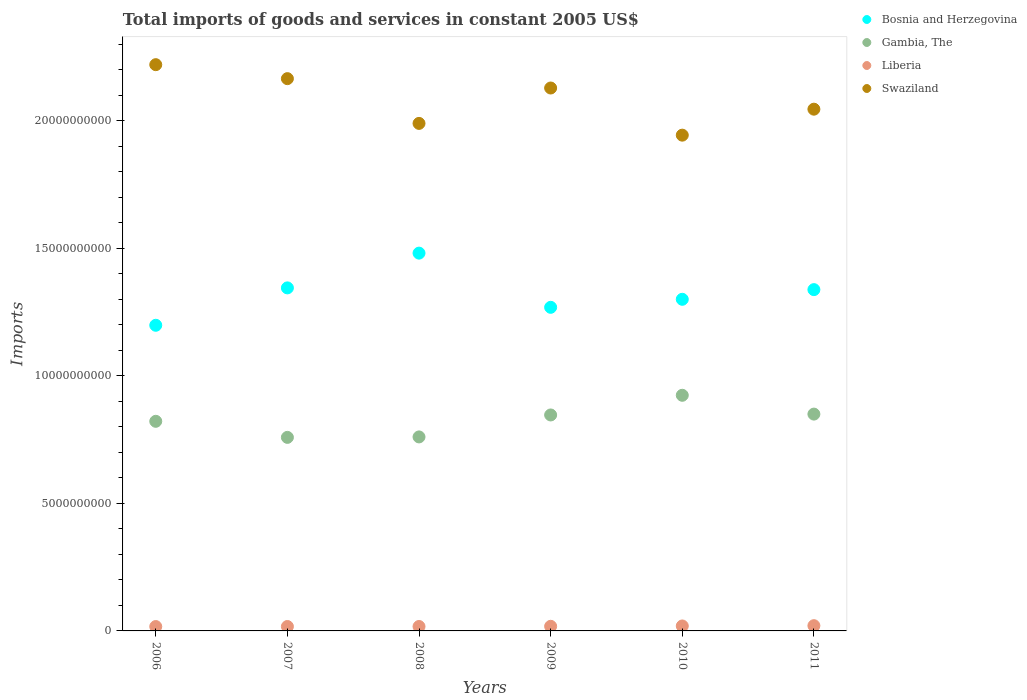How many different coloured dotlines are there?
Ensure brevity in your answer.  4. Is the number of dotlines equal to the number of legend labels?
Provide a short and direct response. Yes. What is the total imports of goods and services in Swaziland in 2010?
Your answer should be very brief. 1.94e+1. Across all years, what is the maximum total imports of goods and services in Liberia?
Provide a short and direct response. 2.06e+08. Across all years, what is the minimum total imports of goods and services in Gambia, The?
Keep it short and to the point. 7.59e+09. What is the total total imports of goods and services in Gambia, The in the graph?
Make the answer very short. 4.96e+1. What is the difference between the total imports of goods and services in Liberia in 2006 and that in 2010?
Your answer should be compact. -2.30e+07. What is the difference between the total imports of goods and services in Liberia in 2006 and the total imports of goods and services in Swaziland in 2007?
Your response must be concise. -2.15e+1. What is the average total imports of goods and services in Gambia, The per year?
Offer a terse response. 8.27e+09. In the year 2008, what is the difference between the total imports of goods and services in Gambia, The and total imports of goods and services in Swaziland?
Keep it short and to the point. -1.23e+1. What is the ratio of the total imports of goods and services in Gambia, The in 2007 to that in 2011?
Your answer should be very brief. 0.89. Is the total imports of goods and services in Bosnia and Herzegovina in 2008 less than that in 2010?
Keep it short and to the point. No. What is the difference between the highest and the second highest total imports of goods and services in Swaziland?
Give a very brief answer. 5.48e+08. What is the difference between the highest and the lowest total imports of goods and services in Gambia, The?
Offer a very short reply. 1.65e+09. In how many years, is the total imports of goods and services in Gambia, The greater than the average total imports of goods and services in Gambia, The taken over all years?
Your response must be concise. 3. Is the sum of the total imports of goods and services in Swaziland in 2008 and 2009 greater than the maximum total imports of goods and services in Gambia, The across all years?
Offer a very short reply. Yes. Does the total imports of goods and services in Bosnia and Herzegovina monotonically increase over the years?
Give a very brief answer. No. Is the total imports of goods and services in Swaziland strictly greater than the total imports of goods and services in Bosnia and Herzegovina over the years?
Provide a short and direct response. Yes. Is the total imports of goods and services in Swaziland strictly less than the total imports of goods and services in Gambia, The over the years?
Keep it short and to the point. No. How many years are there in the graph?
Your response must be concise. 6. What is the difference between two consecutive major ticks on the Y-axis?
Ensure brevity in your answer.  5.00e+09. Does the graph contain grids?
Your answer should be very brief. No. Where does the legend appear in the graph?
Ensure brevity in your answer.  Top right. How many legend labels are there?
Offer a very short reply. 4. How are the legend labels stacked?
Your response must be concise. Vertical. What is the title of the graph?
Offer a terse response. Total imports of goods and services in constant 2005 US$. Does "Kazakhstan" appear as one of the legend labels in the graph?
Provide a succinct answer. No. What is the label or title of the X-axis?
Ensure brevity in your answer.  Years. What is the label or title of the Y-axis?
Ensure brevity in your answer.  Imports. What is the Imports in Bosnia and Herzegovina in 2006?
Your response must be concise. 1.20e+1. What is the Imports of Gambia, The in 2006?
Your answer should be compact. 8.22e+09. What is the Imports of Liberia in 2006?
Your answer should be compact. 1.71e+08. What is the Imports in Swaziland in 2006?
Your answer should be very brief. 2.22e+1. What is the Imports of Bosnia and Herzegovina in 2007?
Provide a succinct answer. 1.35e+1. What is the Imports of Gambia, The in 2007?
Your response must be concise. 7.59e+09. What is the Imports of Liberia in 2007?
Your answer should be very brief. 1.73e+08. What is the Imports in Swaziland in 2007?
Your response must be concise. 2.17e+1. What is the Imports in Bosnia and Herzegovina in 2008?
Offer a terse response. 1.48e+1. What is the Imports in Gambia, The in 2008?
Offer a terse response. 7.61e+09. What is the Imports in Liberia in 2008?
Your answer should be very brief. 1.74e+08. What is the Imports in Swaziland in 2008?
Make the answer very short. 1.99e+1. What is the Imports in Bosnia and Herzegovina in 2009?
Offer a very short reply. 1.27e+1. What is the Imports in Gambia, The in 2009?
Provide a short and direct response. 8.47e+09. What is the Imports in Liberia in 2009?
Ensure brevity in your answer.  1.81e+08. What is the Imports in Swaziland in 2009?
Offer a very short reply. 2.13e+1. What is the Imports of Bosnia and Herzegovina in 2010?
Your answer should be very brief. 1.30e+1. What is the Imports of Gambia, The in 2010?
Provide a short and direct response. 9.24e+09. What is the Imports in Liberia in 2010?
Provide a short and direct response. 1.94e+08. What is the Imports of Swaziland in 2010?
Keep it short and to the point. 1.94e+1. What is the Imports in Bosnia and Herzegovina in 2011?
Your answer should be very brief. 1.34e+1. What is the Imports of Gambia, The in 2011?
Give a very brief answer. 8.50e+09. What is the Imports of Liberia in 2011?
Offer a very short reply. 2.06e+08. What is the Imports in Swaziland in 2011?
Your answer should be very brief. 2.05e+1. Across all years, what is the maximum Imports of Bosnia and Herzegovina?
Your answer should be very brief. 1.48e+1. Across all years, what is the maximum Imports in Gambia, The?
Your answer should be very brief. 9.24e+09. Across all years, what is the maximum Imports in Liberia?
Give a very brief answer. 2.06e+08. Across all years, what is the maximum Imports in Swaziland?
Your response must be concise. 2.22e+1. Across all years, what is the minimum Imports of Bosnia and Herzegovina?
Keep it short and to the point. 1.20e+1. Across all years, what is the minimum Imports in Gambia, The?
Provide a short and direct response. 7.59e+09. Across all years, what is the minimum Imports of Liberia?
Your answer should be very brief. 1.71e+08. Across all years, what is the minimum Imports in Swaziland?
Keep it short and to the point. 1.94e+1. What is the total Imports of Bosnia and Herzegovina in the graph?
Your response must be concise. 7.93e+1. What is the total Imports in Gambia, The in the graph?
Keep it short and to the point. 4.96e+1. What is the total Imports in Liberia in the graph?
Ensure brevity in your answer.  1.10e+09. What is the total Imports of Swaziland in the graph?
Give a very brief answer. 1.25e+11. What is the difference between the Imports of Bosnia and Herzegovina in 2006 and that in 2007?
Ensure brevity in your answer.  -1.47e+09. What is the difference between the Imports in Gambia, The in 2006 and that in 2007?
Offer a terse response. 6.30e+08. What is the difference between the Imports in Liberia in 2006 and that in 2007?
Make the answer very short. -1.79e+06. What is the difference between the Imports in Swaziland in 2006 and that in 2007?
Your answer should be compact. 5.48e+08. What is the difference between the Imports in Bosnia and Herzegovina in 2006 and that in 2008?
Your answer should be very brief. -2.83e+09. What is the difference between the Imports in Gambia, The in 2006 and that in 2008?
Make the answer very short. 6.12e+08. What is the difference between the Imports in Liberia in 2006 and that in 2008?
Provide a short and direct response. -2.40e+06. What is the difference between the Imports in Swaziland in 2006 and that in 2008?
Make the answer very short. 2.30e+09. What is the difference between the Imports in Bosnia and Herzegovina in 2006 and that in 2009?
Your answer should be compact. -7.04e+08. What is the difference between the Imports in Gambia, The in 2006 and that in 2009?
Your response must be concise. -2.49e+08. What is the difference between the Imports in Liberia in 2006 and that in 2009?
Your response must be concise. -9.72e+06. What is the difference between the Imports of Swaziland in 2006 and that in 2009?
Your response must be concise. 9.15e+08. What is the difference between the Imports of Bosnia and Herzegovina in 2006 and that in 2010?
Offer a terse response. -1.02e+09. What is the difference between the Imports in Gambia, The in 2006 and that in 2010?
Offer a very short reply. -1.02e+09. What is the difference between the Imports in Liberia in 2006 and that in 2010?
Your answer should be very brief. -2.30e+07. What is the difference between the Imports of Swaziland in 2006 and that in 2010?
Provide a short and direct response. 2.76e+09. What is the difference between the Imports of Bosnia and Herzegovina in 2006 and that in 2011?
Ensure brevity in your answer.  -1.40e+09. What is the difference between the Imports in Gambia, The in 2006 and that in 2011?
Your answer should be compact. -2.83e+08. What is the difference between the Imports in Liberia in 2006 and that in 2011?
Your answer should be compact. -3.45e+07. What is the difference between the Imports in Swaziland in 2006 and that in 2011?
Offer a terse response. 1.75e+09. What is the difference between the Imports in Bosnia and Herzegovina in 2007 and that in 2008?
Make the answer very short. -1.36e+09. What is the difference between the Imports in Gambia, The in 2007 and that in 2008?
Offer a terse response. -1.79e+07. What is the difference between the Imports in Liberia in 2007 and that in 2008?
Keep it short and to the point. -6.03e+05. What is the difference between the Imports of Swaziland in 2007 and that in 2008?
Provide a succinct answer. 1.76e+09. What is the difference between the Imports in Bosnia and Herzegovina in 2007 and that in 2009?
Keep it short and to the point. 7.62e+08. What is the difference between the Imports in Gambia, The in 2007 and that in 2009?
Keep it short and to the point. -8.79e+08. What is the difference between the Imports of Liberia in 2007 and that in 2009?
Make the answer very short. -7.93e+06. What is the difference between the Imports in Swaziland in 2007 and that in 2009?
Your answer should be very brief. 3.67e+08. What is the difference between the Imports in Bosnia and Herzegovina in 2007 and that in 2010?
Your response must be concise. 4.48e+08. What is the difference between the Imports in Gambia, The in 2007 and that in 2010?
Offer a terse response. -1.65e+09. What is the difference between the Imports in Liberia in 2007 and that in 2010?
Your answer should be compact. -2.12e+07. What is the difference between the Imports of Swaziland in 2007 and that in 2010?
Provide a short and direct response. 2.22e+09. What is the difference between the Imports in Bosnia and Herzegovina in 2007 and that in 2011?
Give a very brief answer. 6.82e+07. What is the difference between the Imports of Gambia, The in 2007 and that in 2011?
Ensure brevity in your answer.  -9.13e+08. What is the difference between the Imports in Liberia in 2007 and that in 2011?
Give a very brief answer. -3.27e+07. What is the difference between the Imports in Swaziland in 2007 and that in 2011?
Give a very brief answer. 1.20e+09. What is the difference between the Imports in Bosnia and Herzegovina in 2008 and that in 2009?
Offer a terse response. 2.13e+09. What is the difference between the Imports in Gambia, The in 2008 and that in 2009?
Give a very brief answer. -8.61e+08. What is the difference between the Imports of Liberia in 2008 and that in 2009?
Keep it short and to the point. -7.32e+06. What is the difference between the Imports of Swaziland in 2008 and that in 2009?
Offer a very short reply. -1.39e+09. What is the difference between the Imports in Bosnia and Herzegovina in 2008 and that in 2010?
Offer a very short reply. 1.81e+09. What is the difference between the Imports in Gambia, The in 2008 and that in 2010?
Make the answer very short. -1.63e+09. What is the difference between the Imports of Liberia in 2008 and that in 2010?
Offer a very short reply. -2.06e+07. What is the difference between the Imports of Swaziland in 2008 and that in 2010?
Provide a succinct answer. 4.61e+08. What is the difference between the Imports of Bosnia and Herzegovina in 2008 and that in 2011?
Provide a succinct answer. 1.43e+09. What is the difference between the Imports of Gambia, The in 2008 and that in 2011?
Provide a short and direct response. -8.95e+08. What is the difference between the Imports of Liberia in 2008 and that in 2011?
Your answer should be compact. -3.21e+07. What is the difference between the Imports in Swaziland in 2008 and that in 2011?
Offer a very short reply. -5.58e+08. What is the difference between the Imports of Bosnia and Herzegovina in 2009 and that in 2010?
Keep it short and to the point. -3.15e+08. What is the difference between the Imports in Gambia, The in 2009 and that in 2010?
Provide a succinct answer. -7.72e+08. What is the difference between the Imports in Liberia in 2009 and that in 2010?
Give a very brief answer. -1.32e+07. What is the difference between the Imports of Swaziland in 2009 and that in 2010?
Your answer should be very brief. 1.85e+09. What is the difference between the Imports of Bosnia and Herzegovina in 2009 and that in 2011?
Your answer should be compact. -6.94e+08. What is the difference between the Imports in Gambia, The in 2009 and that in 2011?
Offer a terse response. -3.38e+07. What is the difference between the Imports of Liberia in 2009 and that in 2011?
Your response must be concise. -2.48e+07. What is the difference between the Imports of Swaziland in 2009 and that in 2011?
Provide a succinct answer. 8.30e+08. What is the difference between the Imports of Bosnia and Herzegovina in 2010 and that in 2011?
Keep it short and to the point. -3.79e+08. What is the difference between the Imports in Gambia, The in 2010 and that in 2011?
Provide a succinct answer. 7.38e+08. What is the difference between the Imports of Liberia in 2010 and that in 2011?
Provide a succinct answer. -1.15e+07. What is the difference between the Imports of Swaziland in 2010 and that in 2011?
Your response must be concise. -1.02e+09. What is the difference between the Imports in Bosnia and Herzegovina in 2006 and the Imports in Gambia, The in 2007?
Offer a terse response. 4.40e+09. What is the difference between the Imports of Bosnia and Herzegovina in 2006 and the Imports of Liberia in 2007?
Offer a very short reply. 1.18e+1. What is the difference between the Imports in Bosnia and Herzegovina in 2006 and the Imports in Swaziland in 2007?
Offer a terse response. -9.67e+09. What is the difference between the Imports of Gambia, The in 2006 and the Imports of Liberia in 2007?
Your response must be concise. 8.05e+09. What is the difference between the Imports in Gambia, The in 2006 and the Imports in Swaziland in 2007?
Offer a terse response. -1.34e+1. What is the difference between the Imports in Liberia in 2006 and the Imports in Swaziland in 2007?
Provide a succinct answer. -2.15e+1. What is the difference between the Imports of Bosnia and Herzegovina in 2006 and the Imports of Gambia, The in 2008?
Offer a very short reply. 4.38e+09. What is the difference between the Imports in Bosnia and Herzegovina in 2006 and the Imports in Liberia in 2008?
Your answer should be very brief. 1.18e+1. What is the difference between the Imports of Bosnia and Herzegovina in 2006 and the Imports of Swaziland in 2008?
Make the answer very short. -7.92e+09. What is the difference between the Imports in Gambia, The in 2006 and the Imports in Liberia in 2008?
Your answer should be compact. 8.05e+09. What is the difference between the Imports in Gambia, The in 2006 and the Imports in Swaziland in 2008?
Offer a very short reply. -1.17e+1. What is the difference between the Imports in Liberia in 2006 and the Imports in Swaziland in 2008?
Your answer should be compact. -1.97e+1. What is the difference between the Imports in Bosnia and Herzegovina in 2006 and the Imports in Gambia, The in 2009?
Your answer should be very brief. 3.52e+09. What is the difference between the Imports in Bosnia and Herzegovina in 2006 and the Imports in Liberia in 2009?
Your answer should be very brief. 1.18e+1. What is the difference between the Imports of Bosnia and Herzegovina in 2006 and the Imports of Swaziland in 2009?
Offer a terse response. -9.31e+09. What is the difference between the Imports of Gambia, The in 2006 and the Imports of Liberia in 2009?
Give a very brief answer. 8.04e+09. What is the difference between the Imports in Gambia, The in 2006 and the Imports in Swaziland in 2009?
Your answer should be very brief. -1.31e+1. What is the difference between the Imports of Liberia in 2006 and the Imports of Swaziland in 2009?
Provide a succinct answer. -2.11e+1. What is the difference between the Imports in Bosnia and Herzegovina in 2006 and the Imports in Gambia, The in 2010?
Make the answer very short. 2.75e+09. What is the difference between the Imports of Bosnia and Herzegovina in 2006 and the Imports of Liberia in 2010?
Offer a terse response. 1.18e+1. What is the difference between the Imports in Bosnia and Herzegovina in 2006 and the Imports in Swaziland in 2010?
Provide a succinct answer. -7.46e+09. What is the difference between the Imports in Gambia, The in 2006 and the Imports in Liberia in 2010?
Offer a very short reply. 8.03e+09. What is the difference between the Imports in Gambia, The in 2006 and the Imports in Swaziland in 2010?
Offer a very short reply. -1.12e+1. What is the difference between the Imports in Liberia in 2006 and the Imports in Swaziland in 2010?
Offer a very short reply. -1.93e+1. What is the difference between the Imports of Bosnia and Herzegovina in 2006 and the Imports of Gambia, The in 2011?
Keep it short and to the point. 3.48e+09. What is the difference between the Imports of Bosnia and Herzegovina in 2006 and the Imports of Liberia in 2011?
Your response must be concise. 1.18e+1. What is the difference between the Imports in Bosnia and Herzegovina in 2006 and the Imports in Swaziland in 2011?
Provide a short and direct response. -8.47e+09. What is the difference between the Imports in Gambia, The in 2006 and the Imports in Liberia in 2011?
Offer a terse response. 8.01e+09. What is the difference between the Imports of Gambia, The in 2006 and the Imports of Swaziland in 2011?
Your response must be concise. -1.22e+1. What is the difference between the Imports of Liberia in 2006 and the Imports of Swaziland in 2011?
Give a very brief answer. -2.03e+1. What is the difference between the Imports in Bosnia and Herzegovina in 2007 and the Imports in Gambia, The in 2008?
Your response must be concise. 5.84e+09. What is the difference between the Imports of Bosnia and Herzegovina in 2007 and the Imports of Liberia in 2008?
Provide a short and direct response. 1.33e+1. What is the difference between the Imports of Bosnia and Herzegovina in 2007 and the Imports of Swaziland in 2008?
Give a very brief answer. -6.45e+09. What is the difference between the Imports in Gambia, The in 2007 and the Imports in Liberia in 2008?
Ensure brevity in your answer.  7.42e+09. What is the difference between the Imports of Gambia, The in 2007 and the Imports of Swaziland in 2008?
Keep it short and to the point. -1.23e+1. What is the difference between the Imports in Liberia in 2007 and the Imports in Swaziland in 2008?
Ensure brevity in your answer.  -1.97e+1. What is the difference between the Imports in Bosnia and Herzegovina in 2007 and the Imports in Gambia, The in 2009?
Provide a short and direct response. 4.98e+09. What is the difference between the Imports in Bosnia and Herzegovina in 2007 and the Imports in Liberia in 2009?
Your answer should be compact. 1.33e+1. What is the difference between the Imports of Bosnia and Herzegovina in 2007 and the Imports of Swaziland in 2009?
Ensure brevity in your answer.  -7.84e+09. What is the difference between the Imports of Gambia, The in 2007 and the Imports of Liberia in 2009?
Provide a short and direct response. 7.41e+09. What is the difference between the Imports in Gambia, The in 2007 and the Imports in Swaziland in 2009?
Your answer should be very brief. -1.37e+1. What is the difference between the Imports in Liberia in 2007 and the Imports in Swaziland in 2009?
Make the answer very short. -2.11e+1. What is the difference between the Imports of Bosnia and Herzegovina in 2007 and the Imports of Gambia, The in 2010?
Your answer should be very brief. 4.21e+09. What is the difference between the Imports in Bosnia and Herzegovina in 2007 and the Imports in Liberia in 2010?
Give a very brief answer. 1.33e+1. What is the difference between the Imports in Bosnia and Herzegovina in 2007 and the Imports in Swaziland in 2010?
Offer a terse response. -5.99e+09. What is the difference between the Imports in Gambia, The in 2007 and the Imports in Liberia in 2010?
Ensure brevity in your answer.  7.40e+09. What is the difference between the Imports in Gambia, The in 2007 and the Imports in Swaziland in 2010?
Keep it short and to the point. -1.19e+1. What is the difference between the Imports of Liberia in 2007 and the Imports of Swaziland in 2010?
Your response must be concise. -1.93e+1. What is the difference between the Imports in Bosnia and Herzegovina in 2007 and the Imports in Gambia, The in 2011?
Ensure brevity in your answer.  4.95e+09. What is the difference between the Imports in Bosnia and Herzegovina in 2007 and the Imports in Liberia in 2011?
Offer a terse response. 1.32e+1. What is the difference between the Imports of Bosnia and Herzegovina in 2007 and the Imports of Swaziland in 2011?
Your answer should be very brief. -7.01e+09. What is the difference between the Imports in Gambia, The in 2007 and the Imports in Liberia in 2011?
Make the answer very short. 7.38e+09. What is the difference between the Imports of Gambia, The in 2007 and the Imports of Swaziland in 2011?
Ensure brevity in your answer.  -1.29e+1. What is the difference between the Imports of Liberia in 2007 and the Imports of Swaziland in 2011?
Give a very brief answer. -2.03e+1. What is the difference between the Imports in Bosnia and Herzegovina in 2008 and the Imports in Gambia, The in 2009?
Give a very brief answer. 6.35e+09. What is the difference between the Imports of Bosnia and Herzegovina in 2008 and the Imports of Liberia in 2009?
Offer a terse response. 1.46e+1. What is the difference between the Imports of Bosnia and Herzegovina in 2008 and the Imports of Swaziland in 2009?
Provide a succinct answer. -6.48e+09. What is the difference between the Imports of Gambia, The in 2008 and the Imports of Liberia in 2009?
Provide a short and direct response. 7.43e+09. What is the difference between the Imports in Gambia, The in 2008 and the Imports in Swaziland in 2009?
Your response must be concise. -1.37e+1. What is the difference between the Imports in Liberia in 2008 and the Imports in Swaziland in 2009?
Your answer should be very brief. -2.11e+1. What is the difference between the Imports of Bosnia and Herzegovina in 2008 and the Imports of Gambia, The in 2010?
Give a very brief answer. 5.57e+09. What is the difference between the Imports in Bosnia and Herzegovina in 2008 and the Imports in Liberia in 2010?
Provide a short and direct response. 1.46e+1. What is the difference between the Imports of Bosnia and Herzegovina in 2008 and the Imports of Swaziland in 2010?
Provide a short and direct response. -4.63e+09. What is the difference between the Imports in Gambia, The in 2008 and the Imports in Liberia in 2010?
Offer a terse response. 7.41e+09. What is the difference between the Imports in Gambia, The in 2008 and the Imports in Swaziland in 2010?
Offer a very short reply. -1.18e+1. What is the difference between the Imports of Liberia in 2008 and the Imports of Swaziland in 2010?
Offer a very short reply. -1.93e+1. What is the difference between the Imports of Bosnia and Herzegovina in 2008 and the Imports of Gambia, The in 2011?
Keep it short and to the point. 6.31e+09. What is the difference between the Imports in Bosnia and Herzegovina in 2008 and the Imports in Liberia in 2011?
Give a very brief answer. 1.46e+1. What is the difference between the Imports in Bosnia and Herzegovina in 2008 and the Imports in Swaziland in 2011?
Offer a terse response. -5.65e+09. What is the difference between the Imports in Gambia, The in 2008 and the Imports in Liberia in 2011?
Give a very brief answer. 7.40e+09. What is the difference between the Imports of Gambia, The in 2008 and the Imports of Swaziland in 2011?
Offer a very short reply. -1.29e+1. What is the difference between the Imports in Liberia in 2008 and the Imports in Swaziland in 2011?
Your response must be concise. -2.03e+1. What is the difference between the Imports in Bosnia and Herzegovina in 2009 and the Imports in Gambia, The in 2010?
Provide a short and direct response. 3.45e+09. What is the difference between the Imports of Bosnia and Herzegovina in 2009 and the Imports of Liberia in 2010?
Provide a succinct answer. 1.25e+1. What is the difference between the Imports of Bosnia and Herzegovina in 2009 and the Imports of Swaziland in 2010?
Your answer should be compact. -6.75e+09. What is the difference between the Imports of Gambia, The in 2009 and the Imports of Liberia in 2010?
Offer a very short reply. 8.28e+09. What is the difference between the Imports in Gambia, The in 2009 and the Imports in Swaziland in 2010?
Provide a succinct answer. -1.10e+1. What is the difference between the Imports in Liberia in 2009 and the Imports in Swaziland in 2010?
Offer a very short reply. -1.93e+1. What is the difference between the Imports of Bosnia and Herzegovina in 2009 and the Imports of Gambia, The in 2011?
Offer a terse response. 4.19e+09. What is the difference between the Imports in Bosnia and Herzegovina in 2009 and the Imports in Liberia in 2011?
Your answer should be very brief. 1.25e+1. What is the difference between the Imports of Bosnia and Herzegovina in 2009 and the Imports of Swaziland in 2011?
Your answer should be very brief. -7.77e+09. What is the difference between the Imports of Gambia, The in 2009 and the Imports of Liberia in 2011?
Make the answer very short. 8.26e+09. What is the difference between the Imports of Gambia, The in 2009 and the Imports of Swaziland in 2011?
Provide a succinct answer. -1.20e+1. What is the difference between the Imports of Liberia in 2009 and the Imports of Swaziland in 2011?
Your answer should be very brief. -2.03e+1. What is the difference between the Imports of Bosnia and Herzegovina in 2010 and the Imports of Gambia, The in 2011?
Offer a very short reply. 4.50e+09. What is the difference between the Imports of Bosnia and Herzegovina in 2010 and the Imports of Liberia in 2011?
Make the answer very short. 1.28e+1. What is the difference between the Imports in Bosnia and Herzegovina in 2010 and the Imports in Swaziland in 2011?
Provide a succinct answer. -7.46e+09. What is the difference between the Imports in Gambia, The in 2010 and the Imports in Liberia in 2011?
Your answer should be very brief. 9.04e+09. What is the difference between the Imports of Gambia, The in 2010 and the Imports of Swaziland in 2011?
Your response must be concise. -1.12e+1. What is the difference between the Imports in Liberia in 2010 and the Imports in Swaziland in 2011?
Offer a terse response. -2.03e+1. What is the average Imports of Bosnia and Herzegovina per year?
Provide a succinct answer. 1.32e+1. What is the average Imports of Gambia, The per year?
Your response must be concise. 8.27e+09. What is the average Imports in Liberia per year?
Make the answer very short. 1.83e+08. What is the average Imports of Swaziland per year?
Make the answer very short. 2.08e+1. In the year 2006, what is the difference between the Imports in Bosnia and Herzegovina and Imports in Gambia, The?
Make the answer very short. 3.77e+09. In the year 2006, what is the difference between the Imports in Bosnia and Herzegovina and Imports in Liberia?
Give a very brief answer. 1.18e+1. In the year 2006, what is the difference between the Imports of Bosnia and Herzegovina and Imports of Swaziland?
Provide a succinct answer. -1.02e+1. In the year 2006, what is the difference between the Imports of Gambia, The and Imports of Liberia?
Your answer should be very brief. 8.05e+09. In the year 2006, what is the difference between the Imports in Gambia, The and Imports in Swaziland?
Provide a short and direct response. -1.40e+1. In the year 2006, what is the difference between the Imports in Liberia and Imports in Swaziland?
Your response must be concise. -2.20e+1. In the year 2007, what is the difference between the Imports in Bosnia and Herzegovina and Imports in Gambia, The?
Keep it short and to the point. 5.86e+09. In the year 2007, what is the difference between the Imports of Bosnia and Herzegovina and Imports of Liberia?
Provide a short and direct response. 1.33e+1. In the year 2007, what is the difference between the Imports in Bosnia and Herzegovina and Imports in Swaziland?
Provide a short and direct response. -8.21e+09. In the year 2007, what is the difference between the Imports in Gambia, The and Imports in Liberia?
Your answer should be very brief. 7.42e+09. In the year 2007, what is the difference between the Imports of Gambia, The and Imports of Swaziland?
Provide a short and direct response. -1.41e+1. In the year 2007, what is the difference between the Imports of Liberia and Imports of Swaziland?
Offer a terse response. -2.15e+1. In the year 2008, what is the difference between the Imports of Bosnia and Herzegovina and Imports of Gambia, The?
Your answer should be very brief. 7.21e+09. In the year 2008, what is the difference between the Imports in Bosnia and Herzegovina and Imports in Liberia?
Offer a terse response. 1.46e+1. In the year 2008, what is the difference between the Imports of Bosnia and Herzegovina and Imports of Swaziland?
Offer a very short reply. -5.09e+09. In the year 2008, what is the difference between the Imports of Gambia, The and Imports of Liberia?
Your answer should be compact. 7.43e+09. In the year 2008, what is the difference between the Imports in Gambia, The and Imports in Swaziland?
Your response must be concise. -1.23e+1. In the year 2008, what is the difference between the Imports in Liberia and Imports in Swaziland?
Make the answer very short. -1.97e+1. In the year 2009, what is the difference between the Imports of Bosnia and Herzegovina and Imports of Gambia, The?
Provide a short and direct response. 4.22e+09. In the year 2009, what is the difference between the Imports of Bosnia and Herzegovina and Imports of Liberia?
Make the answer very short. 1.25e+1. In the year 2009, what is the difference between the Imports in Bosnia and Herzegovina and Imports in Swaziland?
Your response must be concise. -8.60e+09. In the year 2009, what is the difference between the Imports of Gambia, The and Imports of Liberia?
Ensure brevity in your answer.  8.29e+09. In the year 2009, what is the difference between the Imports of Gambia, The and Imports of Swaziland?
Keep it short and to the point. -1.28e+1. In the year 2009, what is the difference between the Imports of Liberia and Imports of Swaziland?
Your answer should be compact. -2.11e+1. In the year 2010, what is the difference between the Imports of Bosnia and Herzegovina and Imports of Gambia, The?
Your answer should be compact. 3.76e+09. In the year 2010, what is the difference between the Imports of Bosnia and Herzegovina and Imports of Liberia?
Provide a short and direct response. 1.28e+1. In the year 2010, what is the difference between the Imports of Bosnia and Herzegovina and Imports of Swaziland?
Offer a very short reply. -6.44e+09. In the year 2010, what is the difference between the Imports in Gambia, The and Imports in Liberia?
Ensure brevity in your answer.  9.05e+09. In the year 2010, what is the difference between the Imports of Gambia, The and Imports of Swaziland?
Make the answer very short. -1.02e+1. In the year 2010, what is the difference between the Imports of Liberia and Imports of Swaziland?
Offer a very short reply. -1.92e+1. In the year 2011, what is the difference between the Imports in Bosnia and Herzegovina and Imports in Gambia, The?
Your response must be concise. 4.88e+09. In the year 2011, what is the difference between the Imports in Bosnia and Herzegovina and Imports in Liberia?
Your answer should be very brief. 1.32e+1. In the year 2011, what is the difference between the Imports of Bosnia and Herzegovina and Imports of Swaziland?
Make the answer very short. -7.08e+09. In the year 2011, what is the difference between the Imports of Gambia, The and Imports of Liberia?
Your answer should be compact. 8.30e+09. In the year 2011, what is the difference between the Imports in Gambia, The and Imports in Swaziland?
Your answer should be compact. -1.20e+1. In the year 2011, what is the difference between the Imports in Liberia and Imports in Swaziland?
Offer a terse response. -2.03e+1. What is the ratio of the Imports in Bosnia and Herzegovina in 2006 to that in 2007?
Offer a very short reply. 0.89. What is the ratio of the Imports in Gambia, The in 2006 to that in 2007?
Your answer should be compact. 1.08. What is the ratio of the Imports of Liberia in 2006 to that in 2007?
Offer a terse response. 0.99. What is the ratio of the Imports in Swaziland in 2006 to that in 2007?
Keep it short and to the point. 1.03. What is the ratio of the Imports of Bosnia and Herzegovina in 2006 to that in 2008?
Ensure brevity in your answer.  0.81. What is the ratio of the Imports of Gambia, The in 2006 to that in 2008?
Provide a succinct answer. 1.08. What is the ratio of the Imports of Liberia in 2006 to that in 2008?
Keep it short and to the point. 0.99. What is the ratio of the Imports in Swaziland in 2006 to that in 2008?
Keep it short and to the point. 1.12. What is the ratio of the Imports in Bosnia and Herzegovina in 2006 to that in 2009?
Provide a short and direct response. 0.94. What is the ratio of the Imports of Gambia, The in 2006 to that in 2009?
Offer a terse response. 0.97. What is the ratio of the Imports in Liberia in 2006 to that in 2009?
Provide a succinct answer. 0.95. What is the ratio of the Imports in Swaziland in 2006 to that in 2009?
Your answer should be compact. 1.04. What is the ratio of the Imports in Bosnia and Herzegovina in 2006 to that in 2010?
Make the answer very short. 0.92. What is the ratio of the Imports of Gambia, The in 2006 to that in 2010?
Give a very brief answer. 0.89. What is the ratio of the Imports in Liberia in 2006 to that in 2010?
Keep it short and to the point. 0.88. What is the ratio of the Imports of Swaziland in 2006 to that in 2010?
Keep it short and to the point. 1.14. What is the ratio of the Imports of Bosnia and Herzegovina in 2006 to that in 2011?
Offer a very short reply. 0.9. What is the ratio of the Imports in Gambia, The in 2006 to that in 2011?
Keep it short and to the point. 0.97. What is the ratio of the Imports of Liberia in 2006 to that in 2011?
Your answer should be compact. 0.83. What is the ratio of the Imports of Swaziland in 2006 to that in 2011?
Give a very brief answer. 1.09. What is the ratio of the Imports in Bosnia and Herzegovina in 2007 to that in 2008?
Provide a succinct answer. 0.91. What is the ratio of the Imports in Swaziland in 2007 to that in 2008?
Offer a very short reply. 1.09. What is the ratio of the Imports in Bosnia and Herzegovina in 2007 to that in 2009?
Your response must be concise. 1.06. What is the ratio of the Imports in Gambia, The in 2007 to that in 2009?
Give a very brief answer. 0.9. What is the ratio of the Imports in Liberia in 2007 to that in 2009?
Give a very brief answer. 0.96. What is the ratio of the Imports in Swaziland in 2007 to that in 2009?
Offer a very short reply. 1.02. What is the ratio of the Imports of Bosnia and Herzegovina in 2007 to that in 2010?
Provide a succinct answer. 1.03. What is the ratio of the Imports of Gambia, The in 2007 to that in 2010?
Keep it short and to the point. 0.82. What is the ratio of the Imports of Liberia in 2007 to that in 2010?
Make the answer very short. 0.89. What is the ratio of the Imports in Swaziland in 2007 to that in 2010?
Offer a terse response. 1.11. What is the ratio of the Imports of Gambia, The in 2007 to that in 2011?
Provide a short and direct response. 0.89. What is the ratio of the Imports of Liberia in 2007 to that in 2011?
Your answer should be compact. 0.84. What is the ratio of the Imports in Swaziland in 2007 to that in 2011?
Give a very brief answer. 1.06. What is the ratio of the Imports of Bosnia and Herzegovina in 2008 to that in 2009?
Offer a very short reply. 1.17. What is the ratio of the Imports of Gambia, The in 2008 to that in 2009?
Provide a succinct answer. 0.9. What is the ratio of the Imports of Liberia in 2008 to that in 2009?
Your response must be concise. 0.96. What is the ratio of the Imports in Swaziland in 2008 to that in 2009?
Keep it short and to the point. 0.93. What is the ratio of the Imports of Bosnia and Herzegovina in 2008 to that in 2010?
Make the answer very short. 1.14. What is the ratio of the Imports in Gambia, The in 2008 to that in 2010?
Your response must be concise. 0.82. What is the ratio of the Imports of Liberia in 2008 to that in 2010?
Your answer should be compact. 0.89. What is the ratio of the Imports in Swaziland in 2008 to that in 2010?
Your answer should be very brief. 1.02. What is the ratio of the Imports in Bosnia and Herzegovina in 2008 to that in 2011?
Ensure brevity in your answer.  1.11. What is the ratio of the Imports of Gambia, The in 2008 to that in 2011?
Provide a succinct answer. 0.89. What is the ratio of the Imports of Liberia in 2008 to that in 2011?
Your answer should be very brief. 0.84. What is the ratio of the Imports in Swaziland in 2008 to that in 2011?
Ensure brevity in your answer.  0.97. What is the ratio of the Imports in Bosnia and Herzegovina in 2009 to that in 2010?
Your response must be concise. 0.98. What is the ratio of the Imports of Gambia, The in 2009 to that in 2010?
Provide a succinct answer. 0.92. What is the ratio of the Imports in Liberia in 2009 to that in 2010?
Offer a terse response. 0.93. What is the ratio of the Imports of Swaziland in 2009 to that in 2010?
Ensure brevity in your answer.  1.1. What is the ratio of the Imports of Bosnia and Herzegovina in 2009 to that in 2011?
Your answer should be compact. 0.95. What is the ratio of the Imports in Liberia in 2009 to that in 2011?
Ensure brevity in your answer.  0.88. What is the ratio of the Imports in Swaziland in 2009 to that in 2011?
Provide a short and direct response. 1.04. What is the ratio of the Imports of Bosnia and Herzegovina in 2010 to that in 2011?
Give a very brief answer. 0.97. What is the ratio of the Imports of Gambia, The in 2010 to that in 2011?
Give a very brief answer. 1.09. What is the ratio of the Imports in Liberia in 2010 to that in 2011?
Offer a terse response. 0.94. What is the ratio of the Imports in Swaziland in 2010 to that in 2011?
Give a very brief answer. 0.95. What is the difference between the highest and the second highest Imports of Bosnia and Herzegovina?
Give a very brief answer. 1.36e+09. What is the difference between the highest and the second highest Imports of Gambia, The?
Your answer should be compact. 7.38e+08. What is the difference between the highest and the second highest Imports in Liberia?
Keep it short and to the point. 1.15e+07. What is the difference between the highest and the second highest Imports in Swaziland?
Ensure brevity in your answer.  5.48e+08. What is the difference between the highest and the lowest Imports in Bosnia and Herzegovina?
Your response must be concise. 2.83e+09. What is the difference between the highest and the lowest Imports in Gambia, The?
Give a very brief answer. 1.65e+09. What is the difference between the highest and the lowest Imports in Liberia?
Offer a very short reply. 3.45e+07. What is the difference between the highest and the lowest Imports of Swaziland?
Your answer should be very brief. 2.76e+09. 